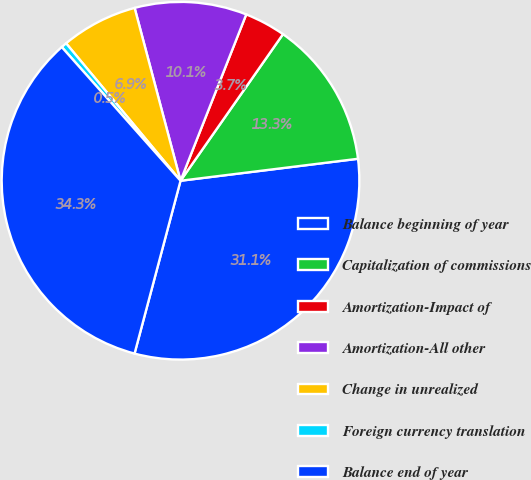Convert chart. <chart><loc_0><loc_0><loc_500><loc_500><pie_chart><fcel>Balance beginning of year<fcel>Capitalization of commissions<fcel>Amortization-Impact of<fcel>Amortization-All other<fcel>Change in unrealized<fcel>Foreign currency translation<fcel>Balance end of year<nl><fcel>31.1%<fcel>13.33%<fcel>3.72%<fcel>10.12%<fcel>6.92%<fcel>0.51%<fcel>34.3%<nl></chart> 